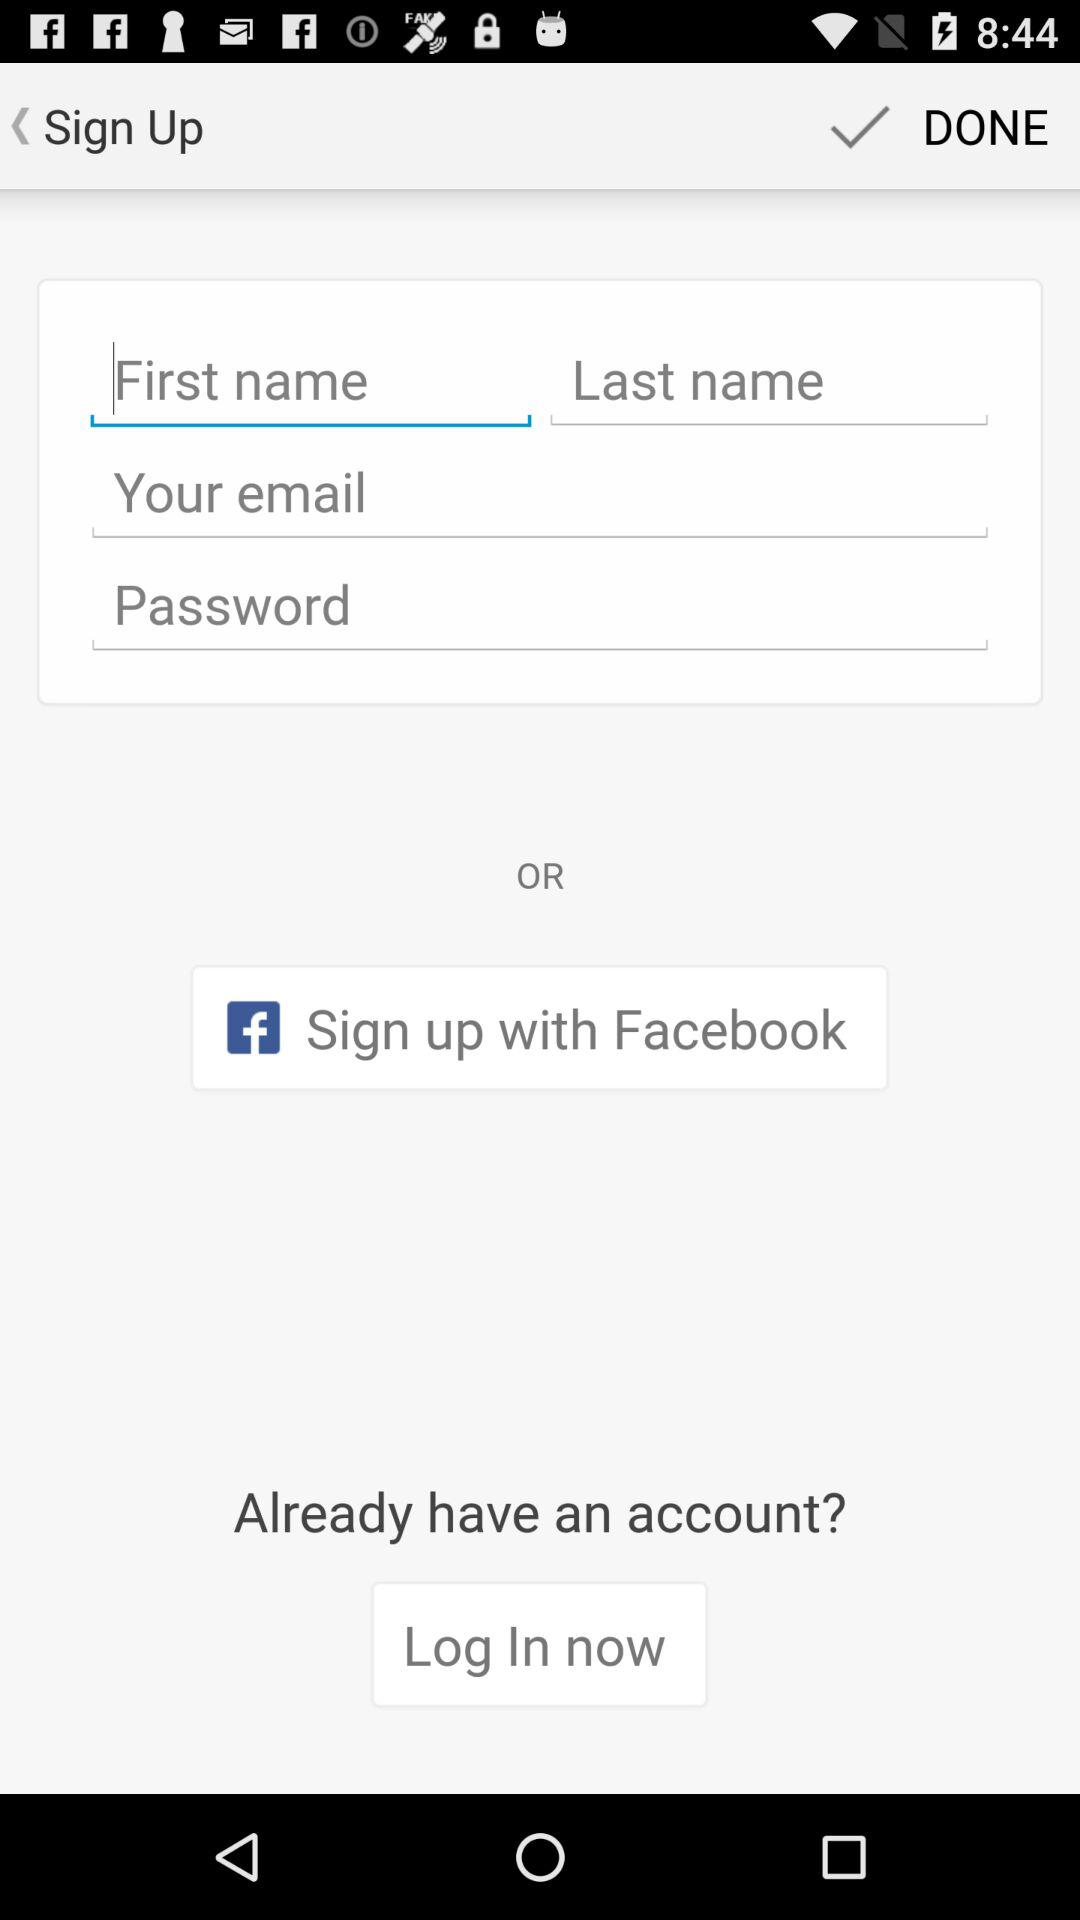How many characters are required to create a password?
When the provided information is insufficient, respond with <no answer>. <no answer> 